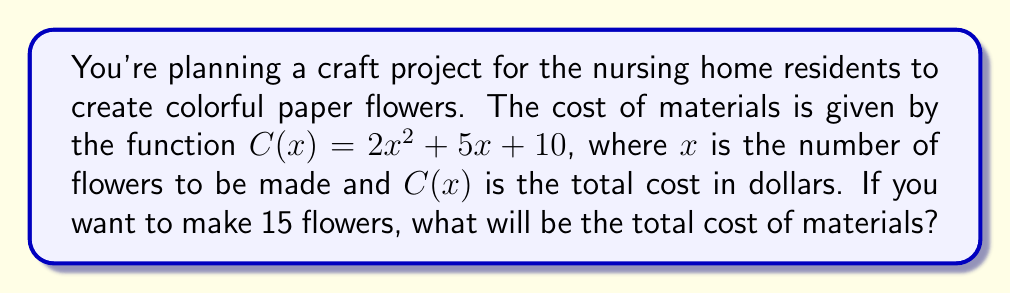Can you answer this question? To solve this problem, we need to follow these steps:

1. Identify the given function: $C(x) = 2x^2 + 5x + 10$

2. Substitute the given value of $x = 15$ into the function:
   $C(15) = 2(15)^2 + 5(15) + 10$

3. Calculate the squared term:
   $C(15) = 2(225) + 5(15) + 10$

4. Multiply:
   $C(15) = 450 + 75 + 10$

5. Add the terms:
   $C(15) = 535$

Therefore, the total cost of materials for making 15 paper flowers will be $535.
Answer: $535 